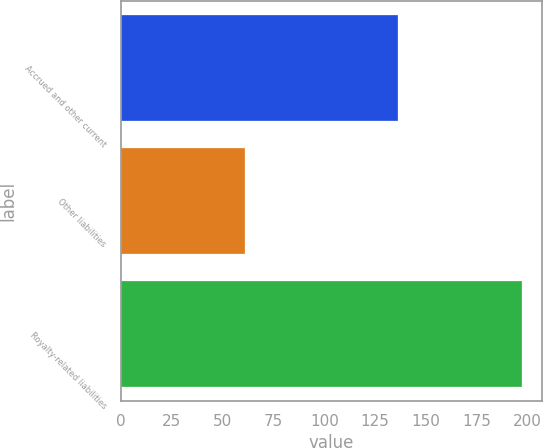Convert chart. <chart><loc_0><loc_0><loc_500><loc_500><bar_chart><fcel>Accrued and other current<fcel>Other liabilities<fcel>Royalty-related liabilities<nl><fcel>136<fcel>61<fcel>197<nl></chart> 